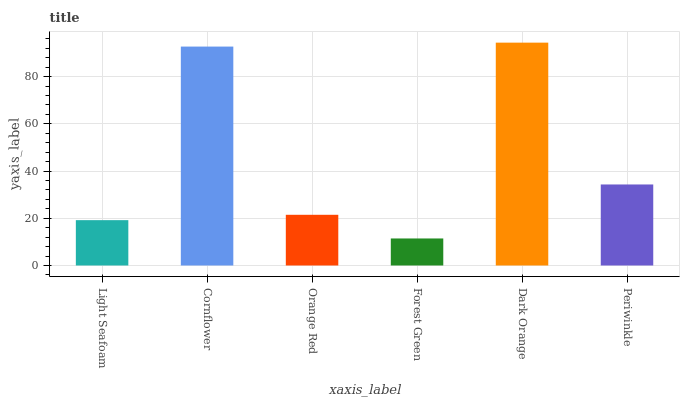Is Forest Green the minimum?
Answer yes or no. Yes. Is Dark Orange the maximum?
Answer yes or no. Yes. Is Cornflower the minimum?
Answer yes or no. No. Is Cornflower the maximum?
Answer yes or no. No. Is Cornflower greater than Light Seafoam?
Answer yes or no. Yes. Is Light Seafoam less than Cornflower?
Answer yes or no. Yes. Is Light Seafoam greater than Cornflower?
Answer yes or no. No. Is Cornflower less than Light Seafoam?
Answer yes or no. No. Is Periwinkle the high median?
Answer yes or no. Yes. Is Orange Red the low median?
Answer yes or no. Yes. Is Orange Red the high median?
Answer yes or no. No. Is Cornflower the low median?
Answer yes or no. No. 